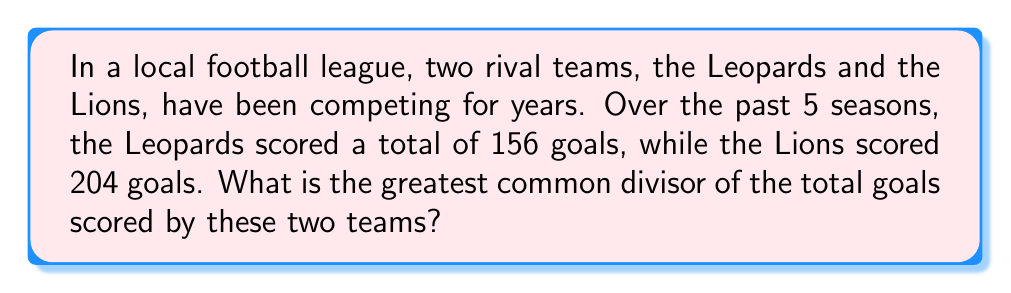Could you help me with this problem? To find the greatest common divisor (GCD) of 156 and 204, we can use the Euclidean algorithm:

1) First, divide 204 by 156:
   $204 = 1 \times 156 + 48$

2) Now divide 156 by 48:
   $156 = 3 \times 48 + 12$

3) Divide 48 by 12:
   $48 = 4 \times 12 + 0$

4) The process stops when we get a remainder of 0.

5) The last non-zero remainder is 12, so this is the GCD.

We can verify:
$156 = 13 \times 12$
$204 = 17 \times 12$

Therefore, the greatest common divisor of the total goals scored by the Leopards (156) and the Lions (204) over the past 5 seasons is 12.
Answer: 12 